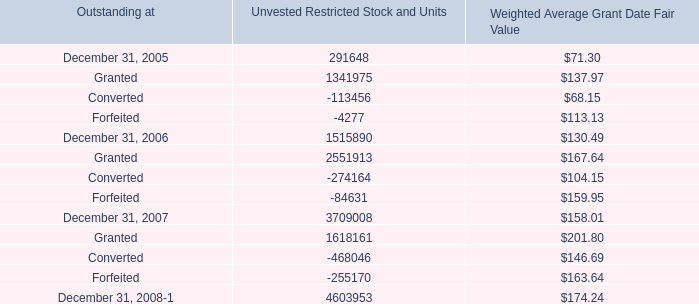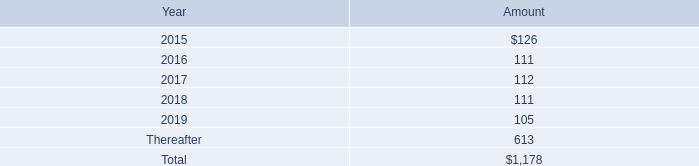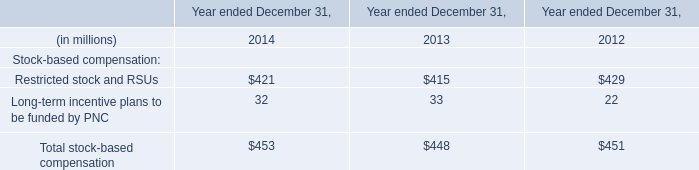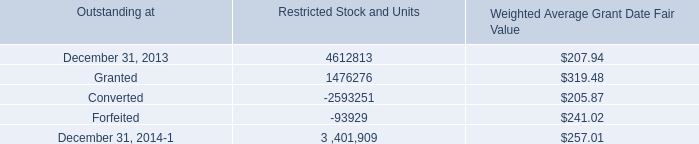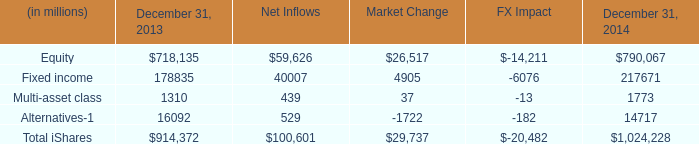What is the average amount of Equity of December 31, 2014, and Granted of Unvested Restricted Stock and Units ? 
Computations: ((790067.0 + 1618161.0) / 2)
Answer: 1204114.0. 